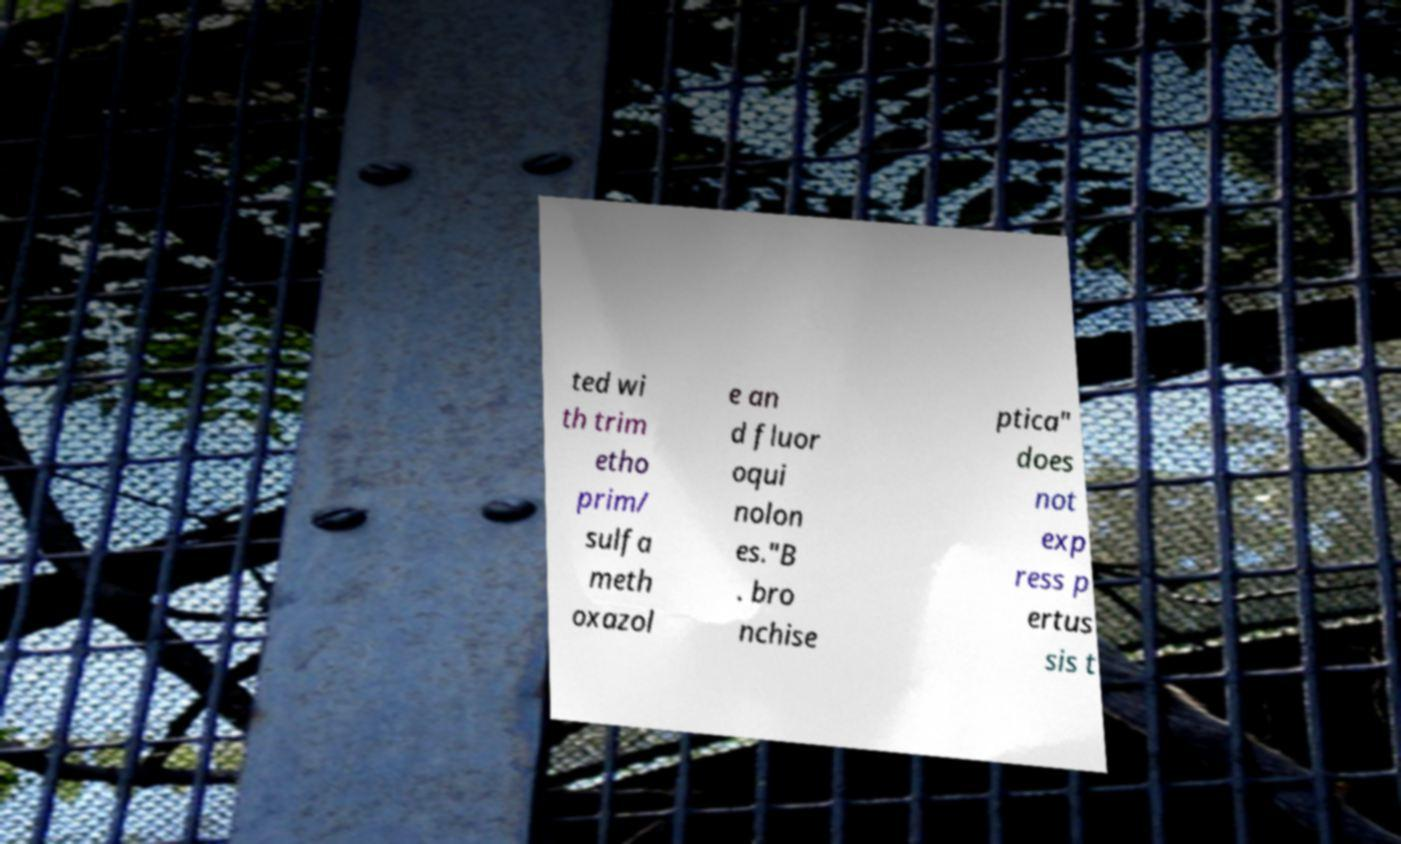Please read and relay the text visible in this image. What does it say? ted wi th trim etho prim/ sulfa meth oxazol e an d fluor oqui nolon es."B . bro nchise ptica" does not exp ress p ertus sis t 